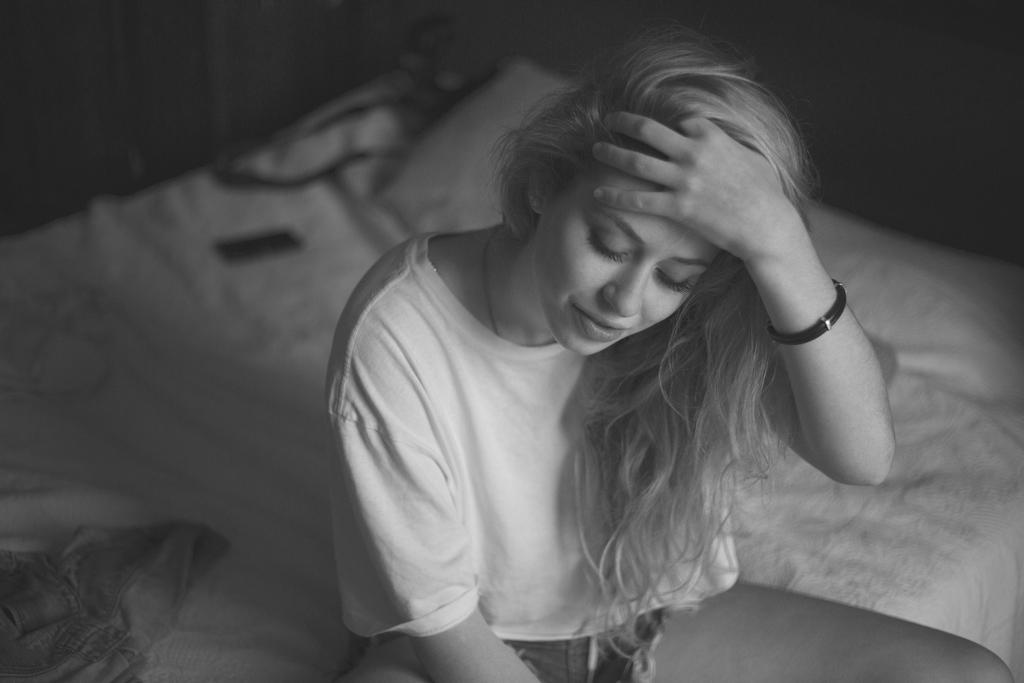Who is in the image? There is a woman in the image. What is the woman doing in the image? The woman is sitting on a bed. What is the woman doing with her hand in the image? The woman has her hand on her hair. How many pies are on the bed in the image? There are no pies present in the image; it only features a woman sitting on a bed. 